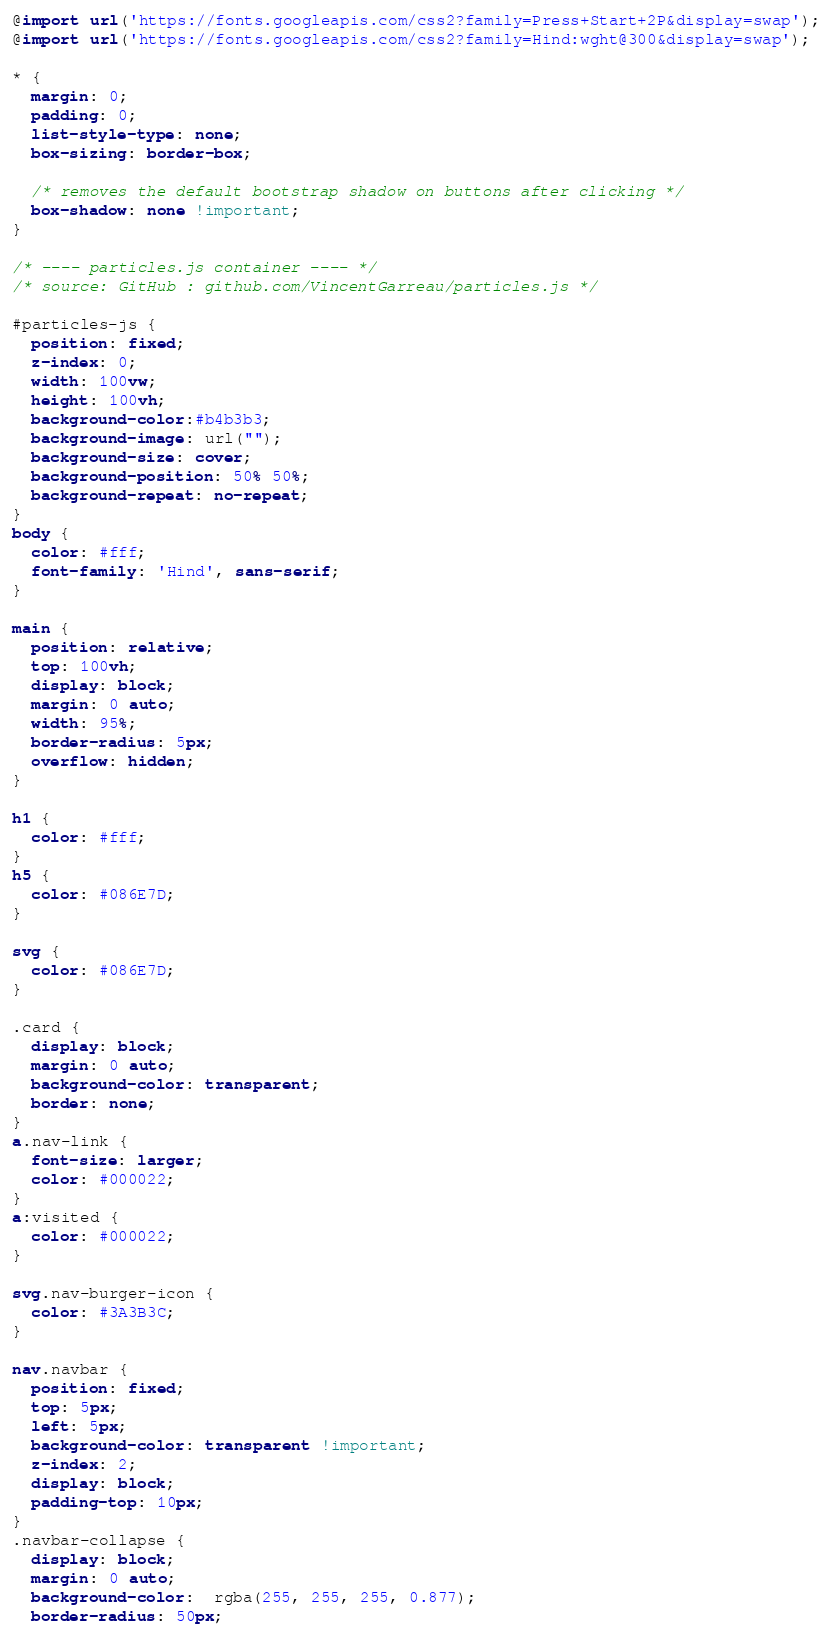<code> <loc_0><loc_0><loc_500><loc_500><_CSS_>@import url('https://fonts.googleapis.com/css2?family=Press+Start+2P&display=swap');
@import url('https://fonts.googleapis.com/css2?family=Hind:wght@300&display=swap');

* {
  margin: 0;
  padding: 0;
  list-style-type: none;
  box-sizing: border-box;

  /* removes the default bootstrap shadow on buttons after clicking */
  box-shadow: none !important;
}

/* ---- particles.js container ---- */
/* source: GitHub : github.com/VincentGarreau/particles.js */

#particles-js {
  position: fixed;
  z-index: 0;
  width: 100vw;
  height: 100vh;
  background-color:#b4b3b3;
  background-image: url("");
  background-size: cover;
  background-position: 50% 50%;
  background-repeat: no-repeat;
}
body {
  color: #fff;
  font-family: 'Hind', sans-serif;
}

main {
  position: relative;
  top: 100vh;
  display: block;
  margin: 0 auto;
  width: 95%;
  border-radius: 5px;
  overflow: hidden;
}

h1 {
  color: #fff;
}
h5 {
  color: #086E7D;
}

svg {
  color: #086E7D;
}

.card {
  display: block;
  margin: 0 auto;
  background-color: transparent;
  border: none;
}
a.nav-link {
  font-size: larger;
  color: #000022;
}
a:visited {
  color: #000022;
}

svg.nav-burger-icon {
  color: #3A3B3C;
}

nav.navbar {
  position: fixed;
  top: 5px;
  left: 5px;
  background-color: transparent !important;
  z-index: 2;
  display: block;
  padding-top: 10px;
}
.navbar-collapse {
  display: block;
  margin: 0 auto;
  background-color:  rgba(255, 255, 255, 0.877);
  border-radius: 50px;</code> 